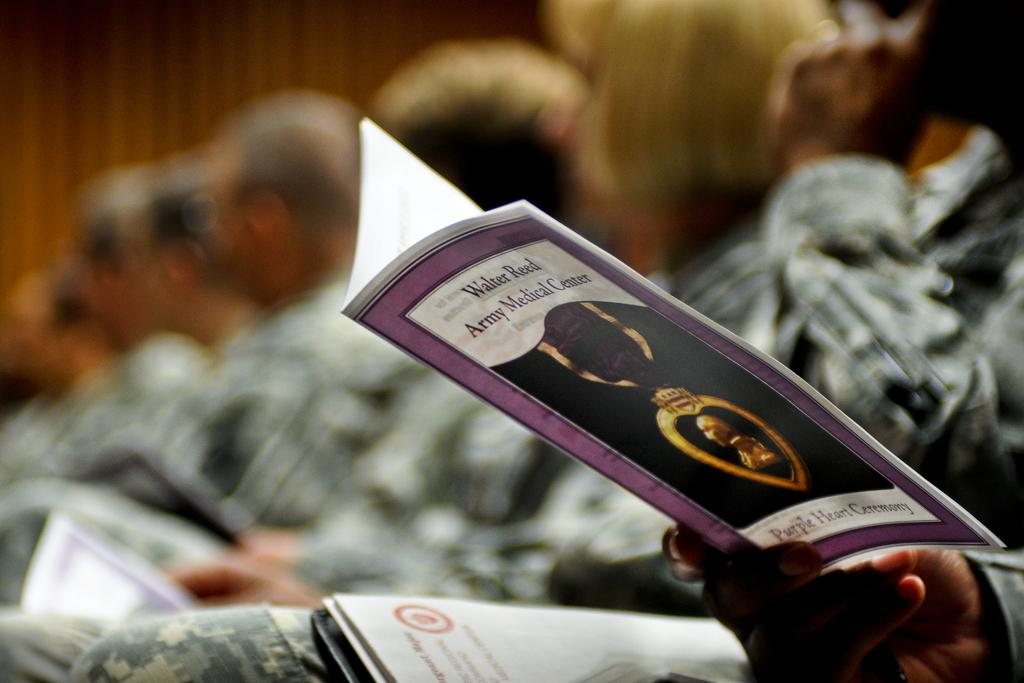<image>
Share a concise interpretation of the image provided. Several people in military uniform sit in a room while one reads a printout for the Walter Reed Army Medical Center Purple Heart Ceremony. 